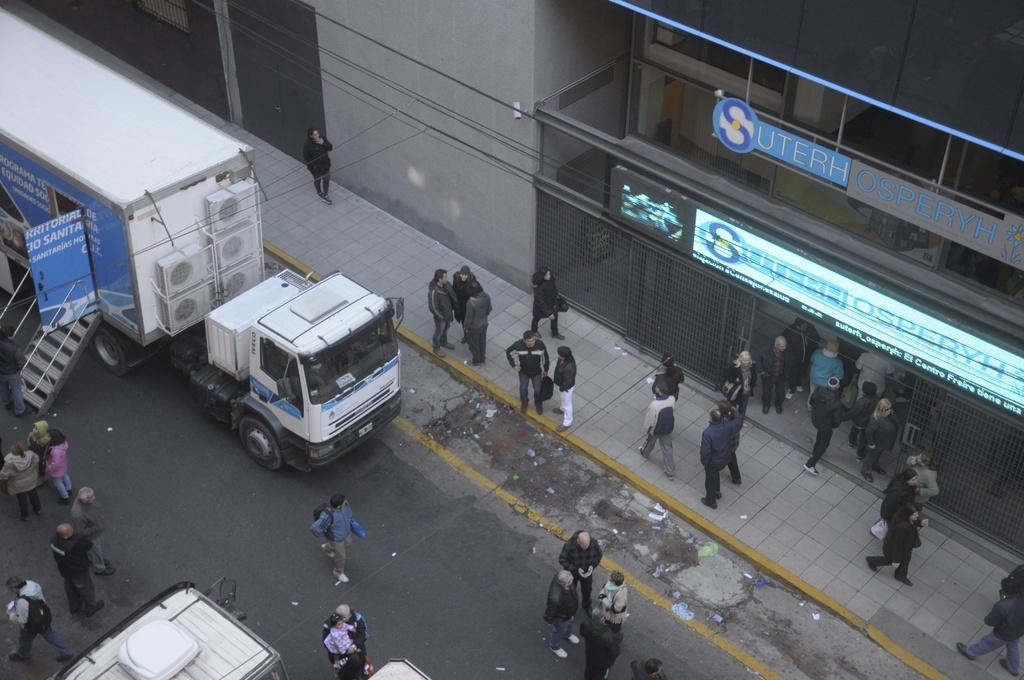What types of objects are present in the image? There are vehicles and people in the image. What else can be seen in the image besides vehicles and people? There are boards in the image. What is visible in the background of the image? There is a building in the background of the image. Can you see any fire in the image? There is no fire present in the image. How many parents are visible in the image? The image does not show any parents; it only shows people in general. 